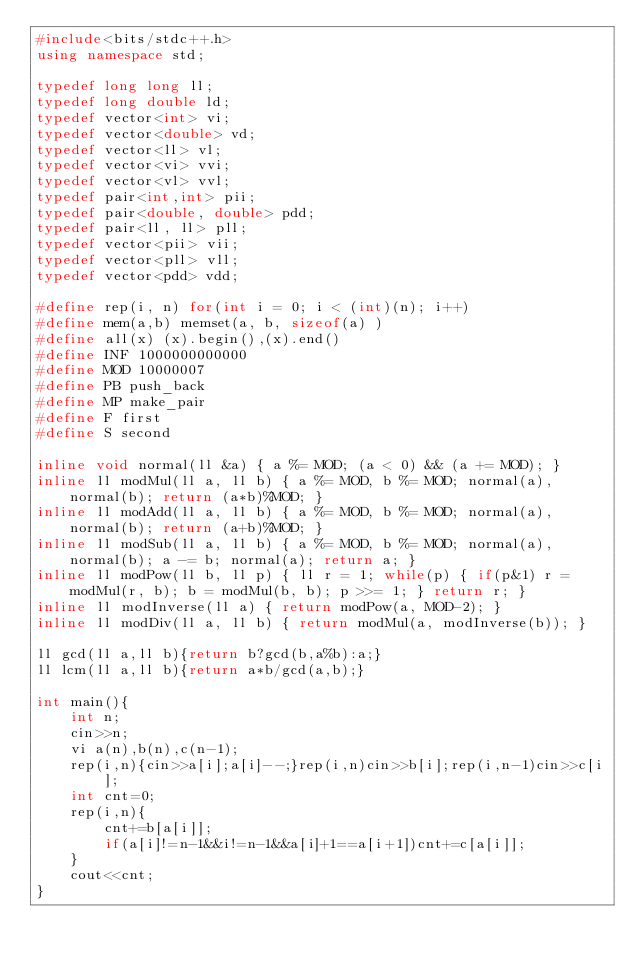<code> <loc_0><loc_0><loc_500><loc_500><_C++_>#include<bits/stdc++.h>
using namespace std;

typedef long long ll;
typedef long double ld;
typedef vector<int> vi;
typedef vector<double> vd;
typedef vector<ll> vl;
typedef vector<vi> vvi;
typedef vector<vl> vvl;
typedef pair<int,int> pii;
typedef pair<double, double> pdd;
typedef pair<ll, ll> pll;
typedef vector<pii> vii;
typedef vector<pll> vll;
typedef vector<pdd> vdd;

#define rep(i, n) for(int i = 0; i < (int)(n); i++)
#define mem(a,b) memset(a, b, sizeof(a) )
#define all(x) (x).begin(),(x).end()
#define INF 1000000000000
#define MOD 10000007
#define PB push_back
#define MP make_pair
#define F first
#define S second

inline void normal(ll &a) { a %= MOD; (a < 0) && (a += MOD); }
inline ll modMul(ll a, ll b) { a %= MOD, b %= MOD; normal(a), normal(b); return (a*b)%MOD; }
inline ll modAdd(ll a, ll b) { a %= MOD, b %= MOD; normal(a), normal(b); return (a+b)%MOD; }
inline ll modSub(ll a, ll b) { a %= MOD, b %= MOD; normal(a), normal(b); a -= b; normal(a); return a; }
inline ll modPow(ll b, ll p) { ll r = 1; while(p) { if(p&1) r = modMul(r, b); b = modMul(b, b); p >>= 1; } return r; }
inline ll modInverse(ll a) { return modPow(a, MOD-2); }
inline ll modDiv(ll a, ll b) { return modMul(a, modInverse(b)); }

ll gcd(ll a,ll b){return b?gcd(b,a%b):a;}
ll lcm(ll a,ll b){return a*b/gcd(a,b);}

int main(){
    int n;
    cin>>n;
    vi a(n),b(n),c(n-1);
    rep(i,n){cin>>a[i];a[i]--;}rep(i,n)cin>>b[i];rep(i,n-1)cin>>c[i];
    int cnt=0;
    rep(i,n){
        cnt+=b[a[i]];
        if(a[i]!=n-1&&i!=n-1&&a[i]+1==a[i+1])cnt+=c[a[i]];
    }
    cout<<cnt;
}</code> 